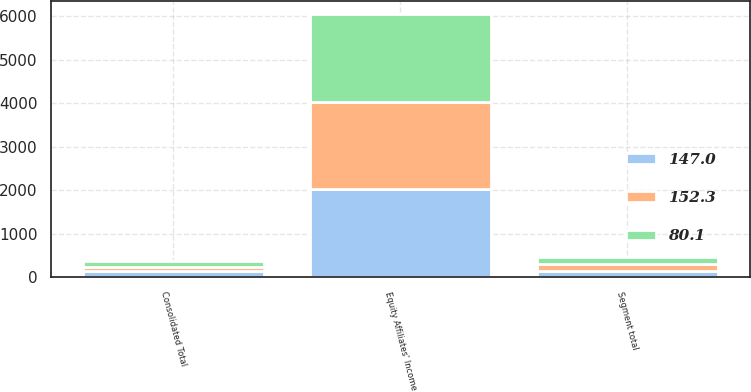Convert chart. <chart><loc_0><loc_0><loc_500><loc_500><stacked_bar_chart><ecel><fcel>Equity Affiliates' Income<fcel>Segment total<fcel>Consolidated Total<nl><fcel>152.3<fcel>2017<fcel>159.6<fcel>80.1<nl><fcel>147<fcel>2016<fcel>147<fcel>147<nl><fcel>80.1<fcel>2015<fcel>152.3<fcel>152.3<nl></chart> 